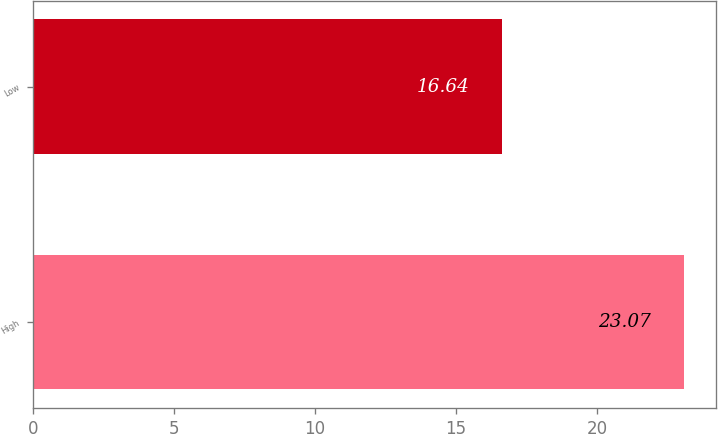Convert chart. <chart><loc_0><loc_0><loc_500><loc_500><bar_chart><fcel>High<fcel>Low<nl><fcel>23.07<fcel>16.64<nl></chart> 